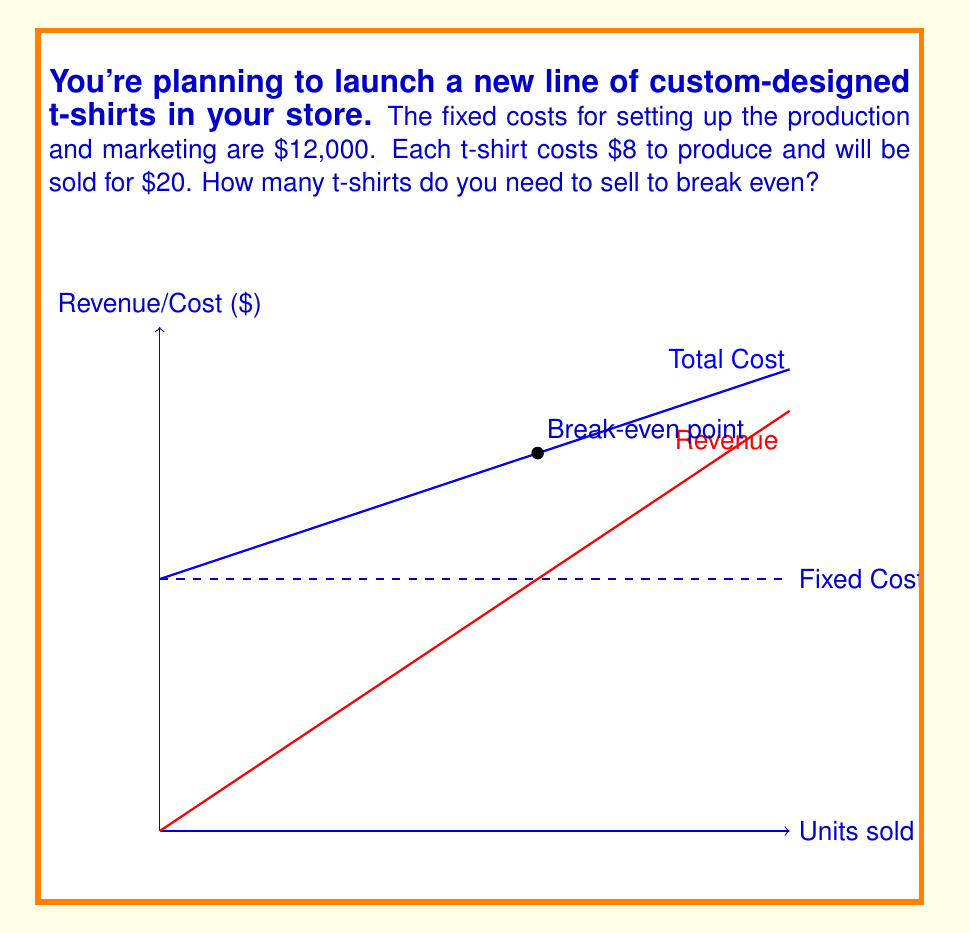Show me your answer to this math problem. To calculate the break-even point, we need to find the number of units where total revenue equals total cost. Let's break this down step-by-step:

1. Define variables:
   Let $x$ = number of t-shirts sold
   Fixed costs (FC) = $12,000
   Variable cost per unit (VC) = $8
   Selling price per unit (P) = $20

2. Set up the break-even equation:
   Total Revenue = Total Cost
   $Px = FC + VCx$

3. Substitute the values:
   $20x = 12,000 + 8x$

4. Solve for x:
   $20x - 8x = 12,000$
   $12x = 12,000$

5. Calculate the break-even point:
   $x = \frac{12,000}{12} = 1,000$

Therefore, you need to sell 1,000 t-shirts to break even.

To verify:
Revenue at 1,000 units: $1,000 \times $20 = $20,000
Total Cost at 1,000 units: $12,000 + (1,000 \times $8) = $20,000

The break-even point occurs where these two values are equal.
Answer: 1,000 t-shirts 